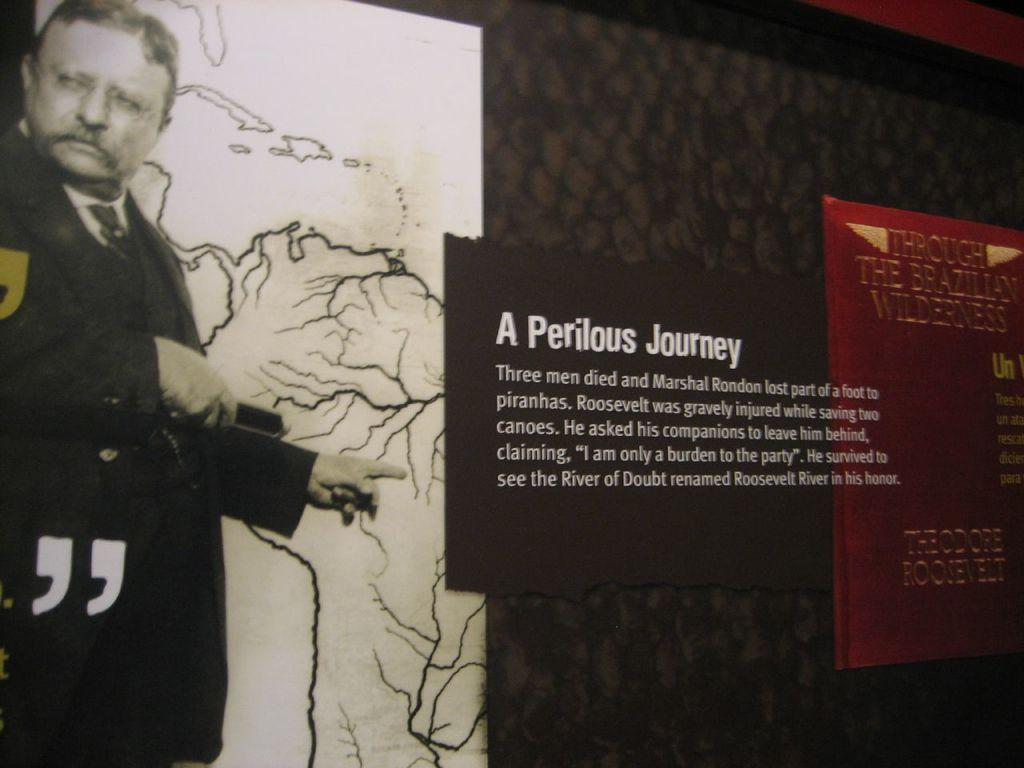<image>
Offer a succinct explanation of the picture presented. A museum wall display labeled A Perilous Journey aith a large image of Theodore Roosevelt. 